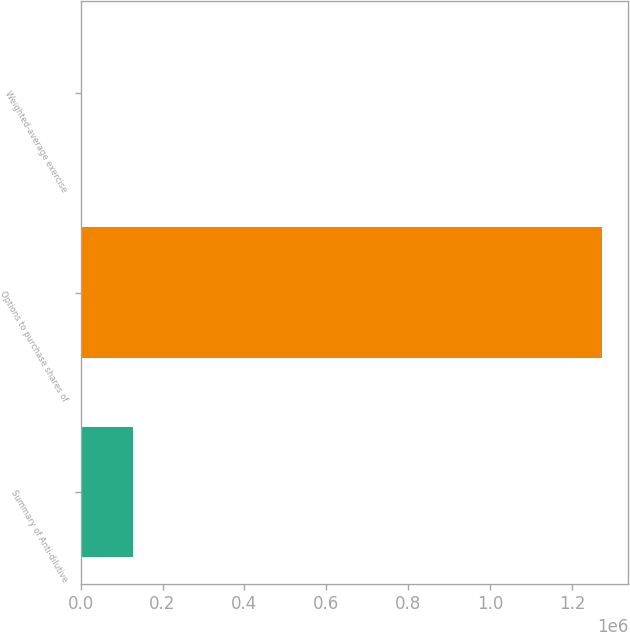Convert chart. <chart><loc_0><loc_0><loc_500><loc_500><bar_chart><fcel>Summary of Anti-dilutive<fcel>Options to purchase shares of<fcel>Weighted-average exercise<nl><fcel>127401<fcel>1.27353e+06<fcel>54<nl></chart> 